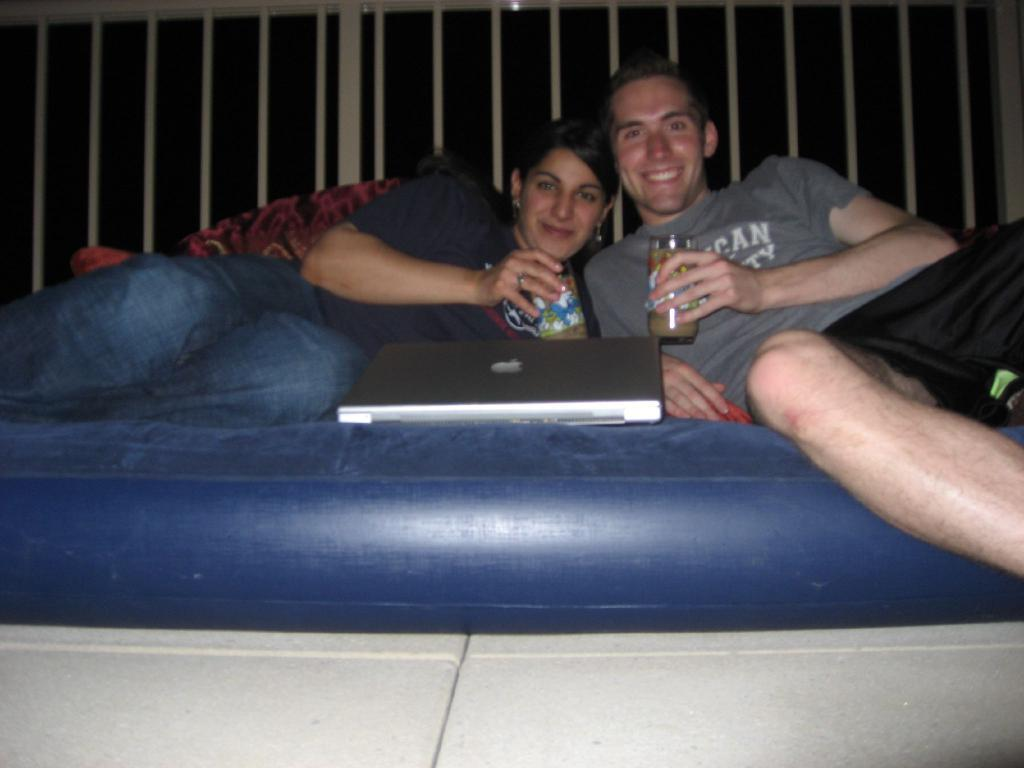Who is present in the image? There is a man and a woman in the image. What are the man and woman doing in the image? The man and woman are lying on an air bed. What objects are the man and woman holding in the image? The man and woman are holding glass tumblers. What electronic device is visible in the image? There is a laptop visible in the image. What language is the expert speaking in the image? There is no expert present in the image, and therefore no language can be identified. 